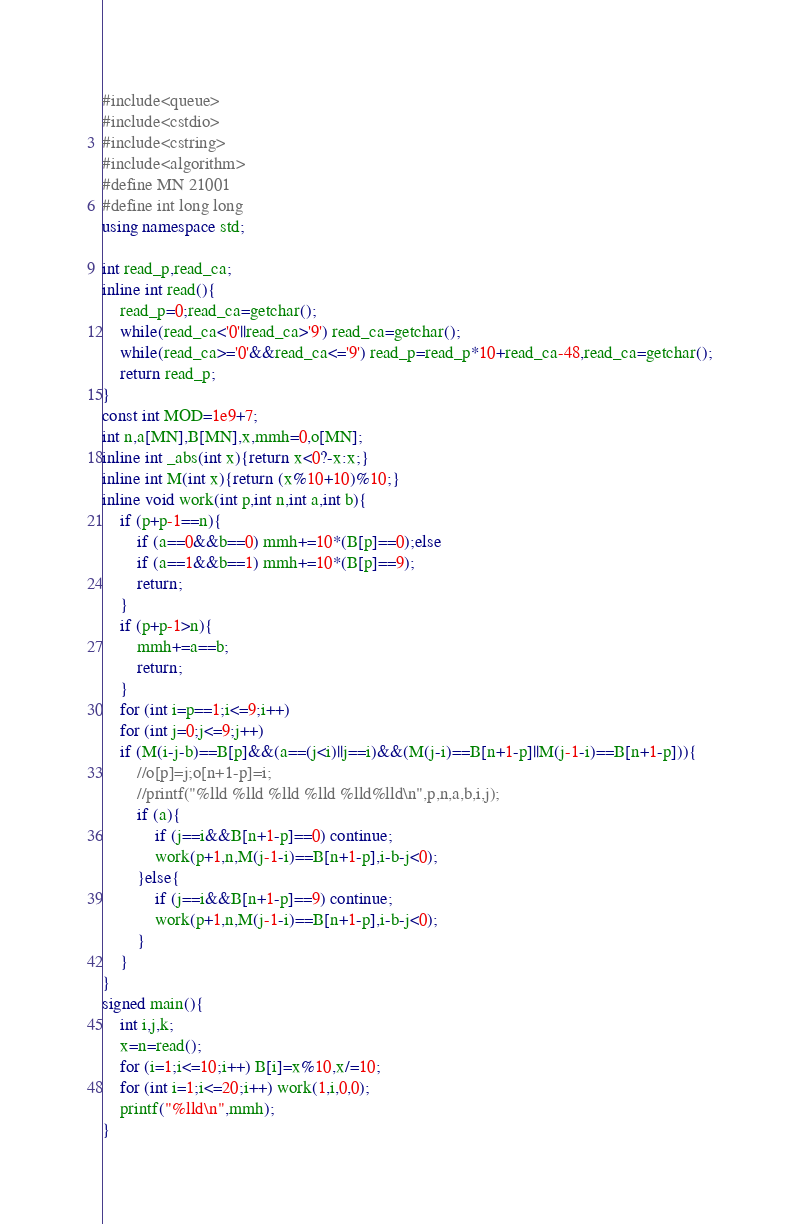<code> <loc_0><loc_0><loc_500><loc_500><_C++_>#include<queue>
#include<cstdio>
#include<cstring>
#include<algorithm>
#define MN 21001
#define int long long
using namespace std;

int read_p,read_ca;
inline int read(){
	read_p=0;read_ca=getchar();
	while(read_ca<'0'||read_ca>'9') read_ca=getchar();
	while(read_ca>='0'&&read_ca<='9') read_p=read_p*10+read_ca-48,read_ca=getchar();
	return read_p;
}
const int MOD=1e9+7;
int n,a[MN],B[MN],x,mmh=0,o[MN];
inline int _abs(int x){return x<0?-x:x;}
inline int M(int x){return (x%10+10)%10;}
inline void work(int p,int n,int a,int b){
	if (p+p-1==n){
		if (a==0&&b==0) mmh+=10*(B[p]==0);else
		if (a==1&&b==1) mmh+=10*(B[p]==9);
		return;
	}
	if (p+p-1>n){
		mmh+=a==b;
		return;
	}
	for (int i=p==1;i<=9;i++)
	for (int j=0;j<=9;j++)
	if (M(i-j-b)==B[p]&&(a==(j<i)||j==i)&&(M(j-i)==B[n+1-p]||M(j-1-i)==B[n+1-p])){
		//o[p]=j;o[n+1-p]=i;
		//printf("%lld %lld %lld %lld %lld%lld\n",p,n,a,b,i,j);
		if (a){
			if (j==i&&B[n+1-p]==0) continue;
			work(p+1,n,M(j-1-i)==B[n+1-p],i-b-j<0);
		}else{
			if (j==i&&B[n+1-p]==9) continue;
			work(p+1,n,M(j-1-i)==B[n+1-p],i-b-j<0);
		}
	}
}
signed main(){
	int i,j,k;
	x=n=read();
	for (i=1;i<=10;i++) B[i]=x%10,x/=10;
	for (int i=1;i<=20;i++) work(1,i,0,0);
	printf("%lld\n",mmh);
}</code> 